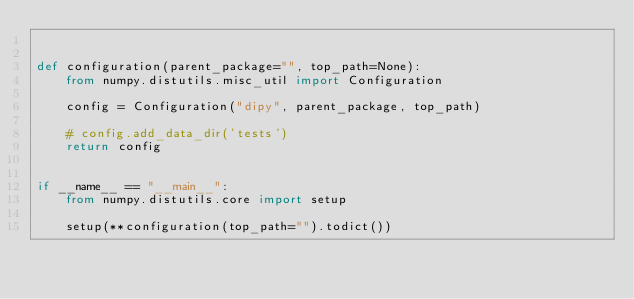Convert code to text. <code><loc_0><loc_0><loc_500><loc_500><_Python_>

def configuration(parent_package="", top_path=None):
    from numpy.distutils.misc_util import Configuration

    config = Configuration("dipy", parent_package, top_path)

    # config.add_data_dir('tests')
    return config


if __name__ == "__main__":
    from numpy.distutils.core import setup

    setup(**configuration(top_path="").todict())
</code> 